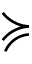Convert formula to latex. <formula><loc_0><loc_0><loc_500><loc_500>\succ c u r l y e q</formula> 